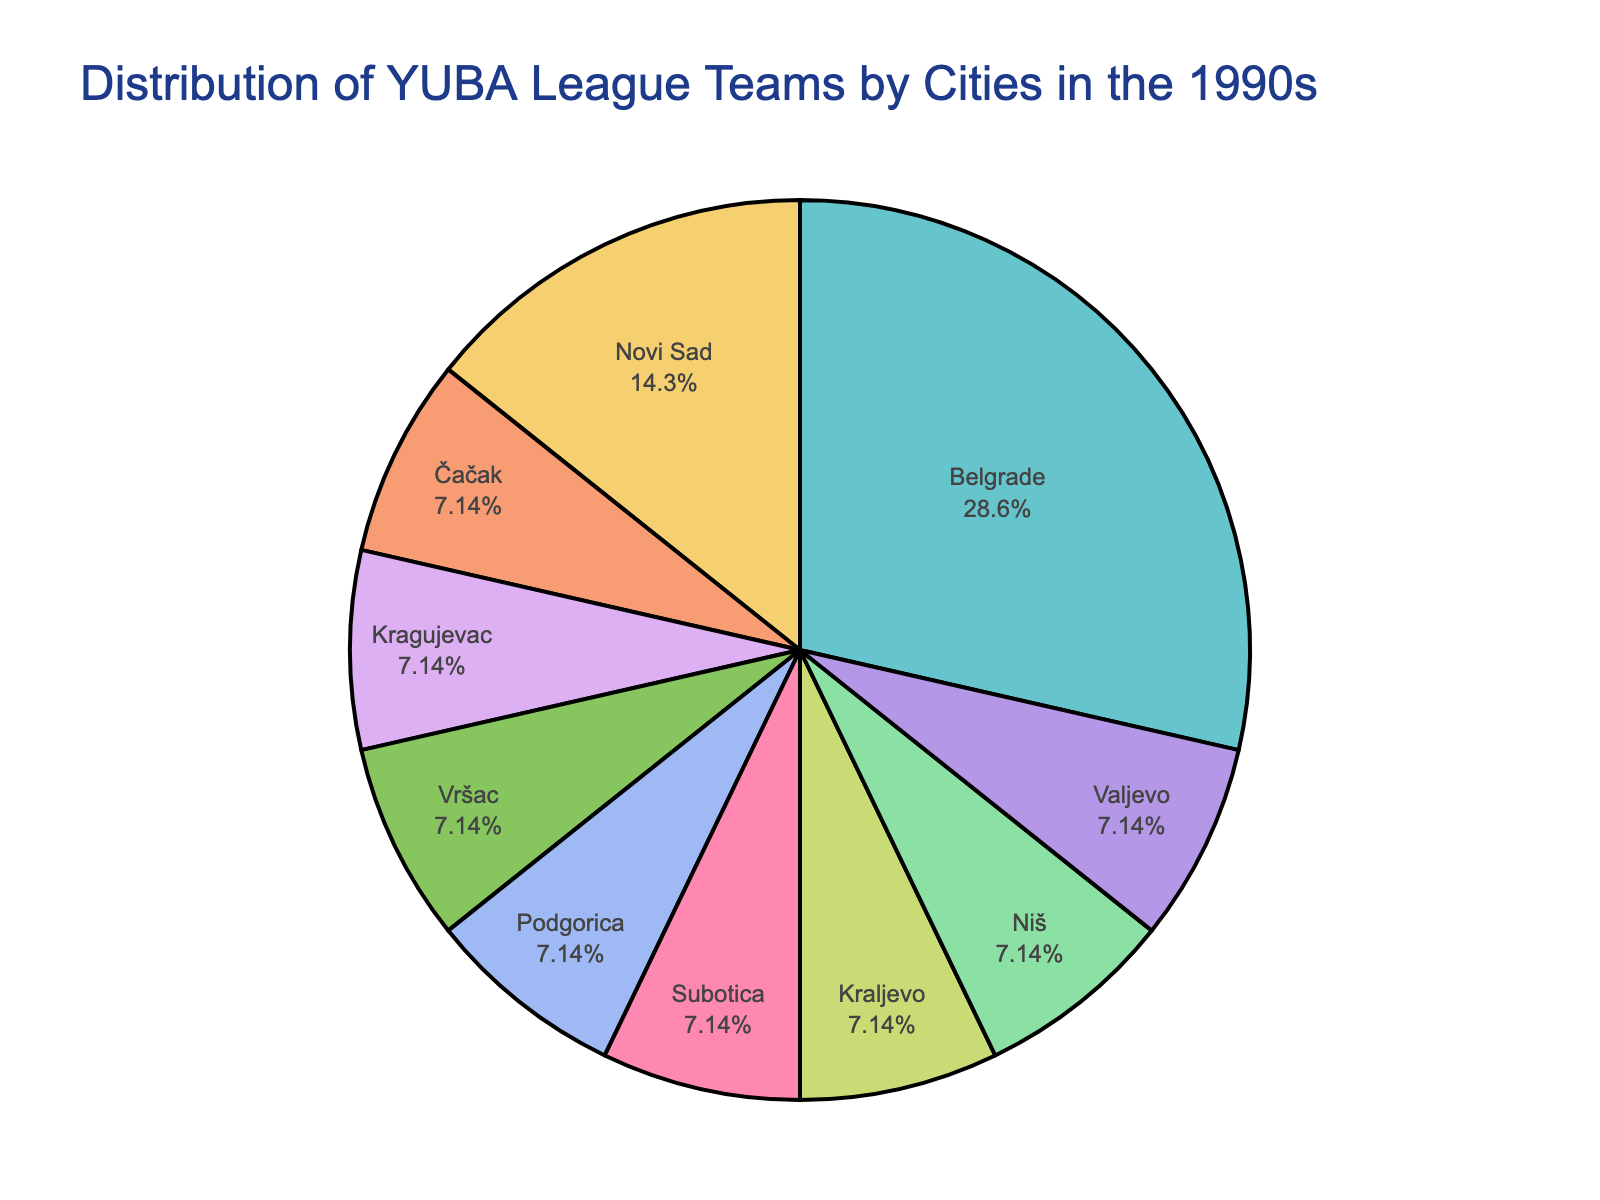Which city has the highest number of YUBA League teams in the 1990s? By looking at the pie chart, identify the city segment that occupies the largest area. This segment will correspond to the city with the highest number of teams.
Answer: Belgrade What percentage of the total teams were based in Belgrade? Refer to the slice representing Belgrade in the pie chart to find the labeled percentage of the total teams.
Answer: 28.57% How many cities had only one YUBA League team in the 1990s? Count the number of slices in the pie chart that represent single teams. Each of these corresponds to one city with only one YUBA League team.
Answer: 8 What is the combined number of teams from Novi Sad and Podgorica? Identify the slices for Novi Sad and Podgorica, then sum the numbers of teams from both cities (Novi Sad: 2, Podgorica: 1).
Answer: 3 Is the number of teams from Belgrade greater than the combined number of teams from all other cities? First, sum the total number of teams from all other cities by adding up the number of teams from each city excluding Belgrade, and compare this to the number of teams from Belgrade (Belgrade: 4; Other cities: 10).
Answer: No Which cities have an equal number of teams? Identify cities with slices that represent the same portion of the pie chart, indicating the same number of teams. The slices representing single teams are examples of this.
Answer: All cities with one team each (Čačak, Kragujevac, Vršac, Podgorica, Subotica, Kraljevo, Niš, Valjevo) What proportion of the total YUBA League teams does Novi Sad represent? Look at the pie chart segment for Novi Sad to identify the labeled percentage it represents of the total teams, or calculate (2 teams / 14 total teams) * 100%.
Answer: 14.29% How does the size of the Subotica slice compare to that of Kraljevo? Compare the visual size of the slices representing Subotica and Kraljevo; since each represents one team, their slices will be the same size.
Answer: Equal What is the average number of teams per city? Sum the total number of teams (14), and divide by the number of cities (10). So, 14 teams / 10 cities.
Answer: 1.4 How does the number of teams from Belgrade compare to Novi Sad, Čačak, and Podgorica combined? Sum the teams from Novi Sad, Čačak, and Podgorica (2 + 1 + 1) and compare this to the number of teams from Belgrade (4).
Answer: Equal 